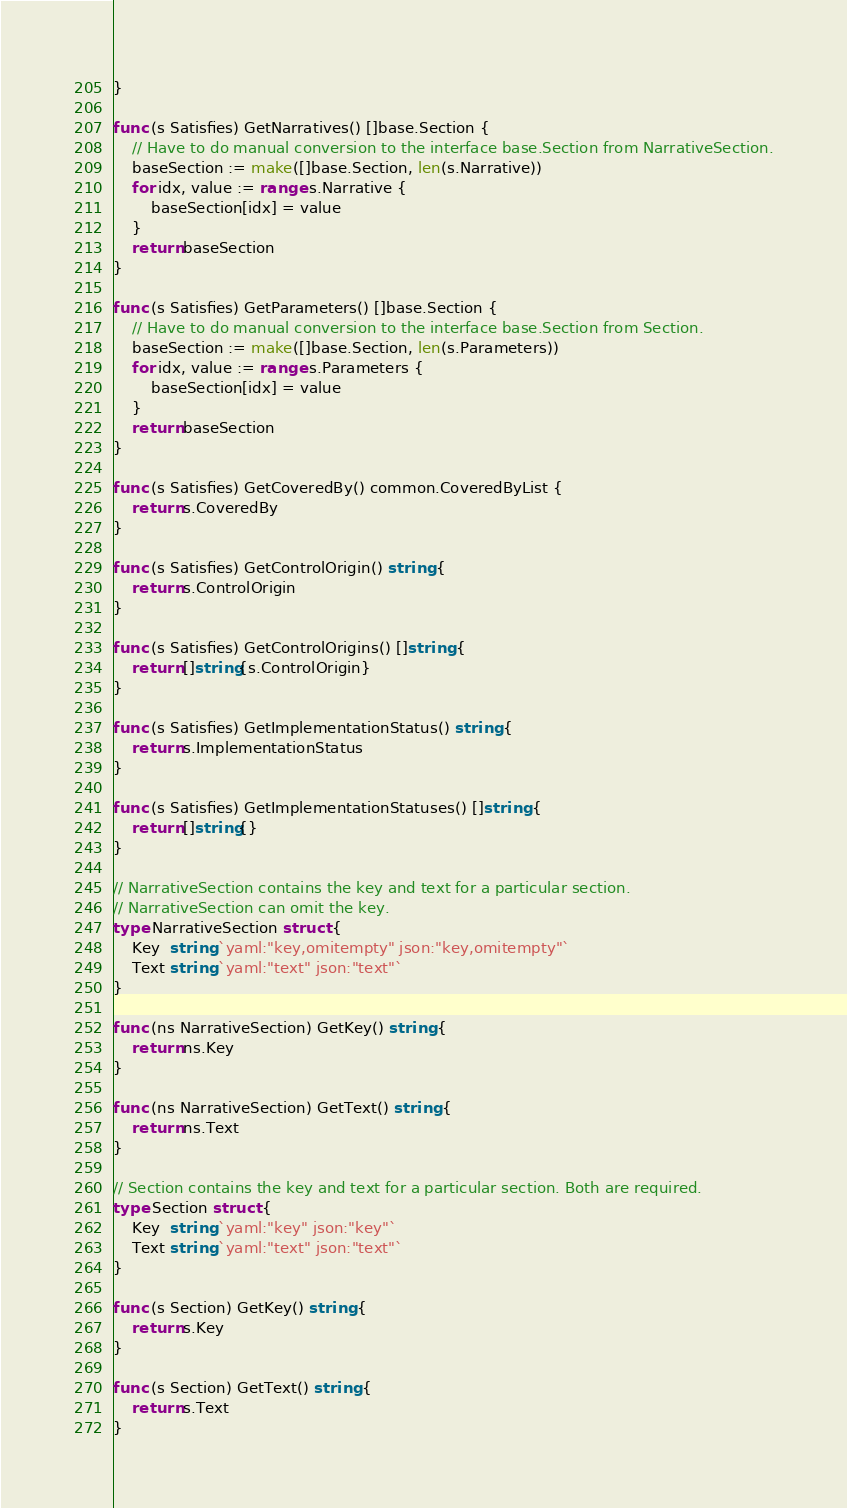Convert code to text. <code><loc_0><loc_0><loc_500><loc_500><_Go_>}

func (s Satisfies) GetNarratives() []base.Section {
	// Have to do manual conversion to the interface base.Section from NarrativeSection.
	baseSection := make([]base.Section, len(s.Narrative))
	for idx, value := range s.Narrative {
		baseSection[idx] = value
	}
	return baseSection
}

func (s Satisfies) GetParameters() []base.Section {
	// Have to do manual conversion to the interface base.Section from Section.
	baseSection := make([]base.Section, len(s.Parameters))
	for idx, value := range s.Parameters {
		baseSection[idx] = value
	}
	return baseSection
}

func (s Satisfies) GetCoveredBy() common.CoveredByList {
	return s.CoveredBy
}

func (s Satisfies) GetControlOrigin() string {
	return s.ControlOrigin
}

func (s Satisfies) GetControlOrigins() []string {
	return []string{s.ControlOrigin}
}

func (s Satisfies) GetImplementationStatus() string {
	return s.ImplementationStatus
}

func (s Satisfies) GetImplementationStatuses() []string {
	return []string{}
}

// NarrativeSection contains the key and text for a particular section.
// NarrativeSection can omit the key.
type NarrativeSection struct {
	Key  string `yaml:"key,omitempty" json:"key,omitempty"`
	Text string `yaml:"text" json:"text"`
}

func (ns NarrativeSection) GetKey() string {
	return ns.Key
}

func (ns NarrativeSection) GetText() string {
	return ns.Text
}

// Section contains the key and text for a particular section. Both are required.
type Section struct {
	Key  string `yaml:"key" json:"key"`
	Text string `yaml:"text" json:"text"`
}

func (s Section) GetKey() string {
	return s.Key
}

func (s Section) GetText() string {
	return s.Text
}
</code> 